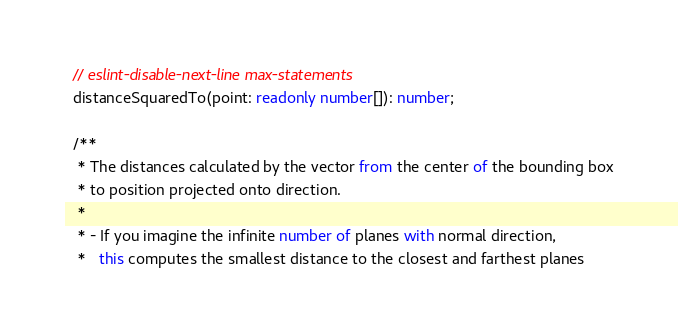<code> <loc_0><loc_0><loc_500><loc_500><_TypeScript_>  // eslint-disable-next-line max-statements
  distanceSquaredTo(point: readonly number[]): number;

  /**
   * The distances calculated by the vector from the center of the bounding box
   * to position projected onto direction.
   *
   * - If you imagine the infinite number of planes with normal direction,
   *   this computes the smallest distance to the closest and farthest planes</code> 